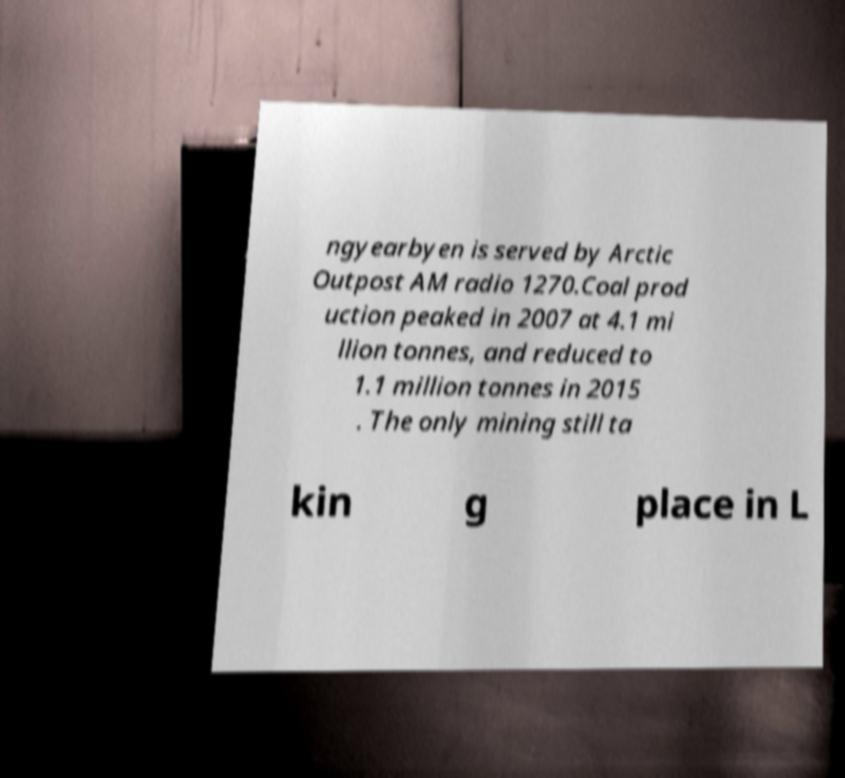Could you assist in decoding the text presented in this image and type it out clearly? ngyearbyen is served by Arctic Outpost AM radio 1270.Coal prod uction peaked in 2007 at 4.1 mi llion tonnes, and reduced to 1.1 million tonnes in 2015 . The only mining still ta kin g place in L 